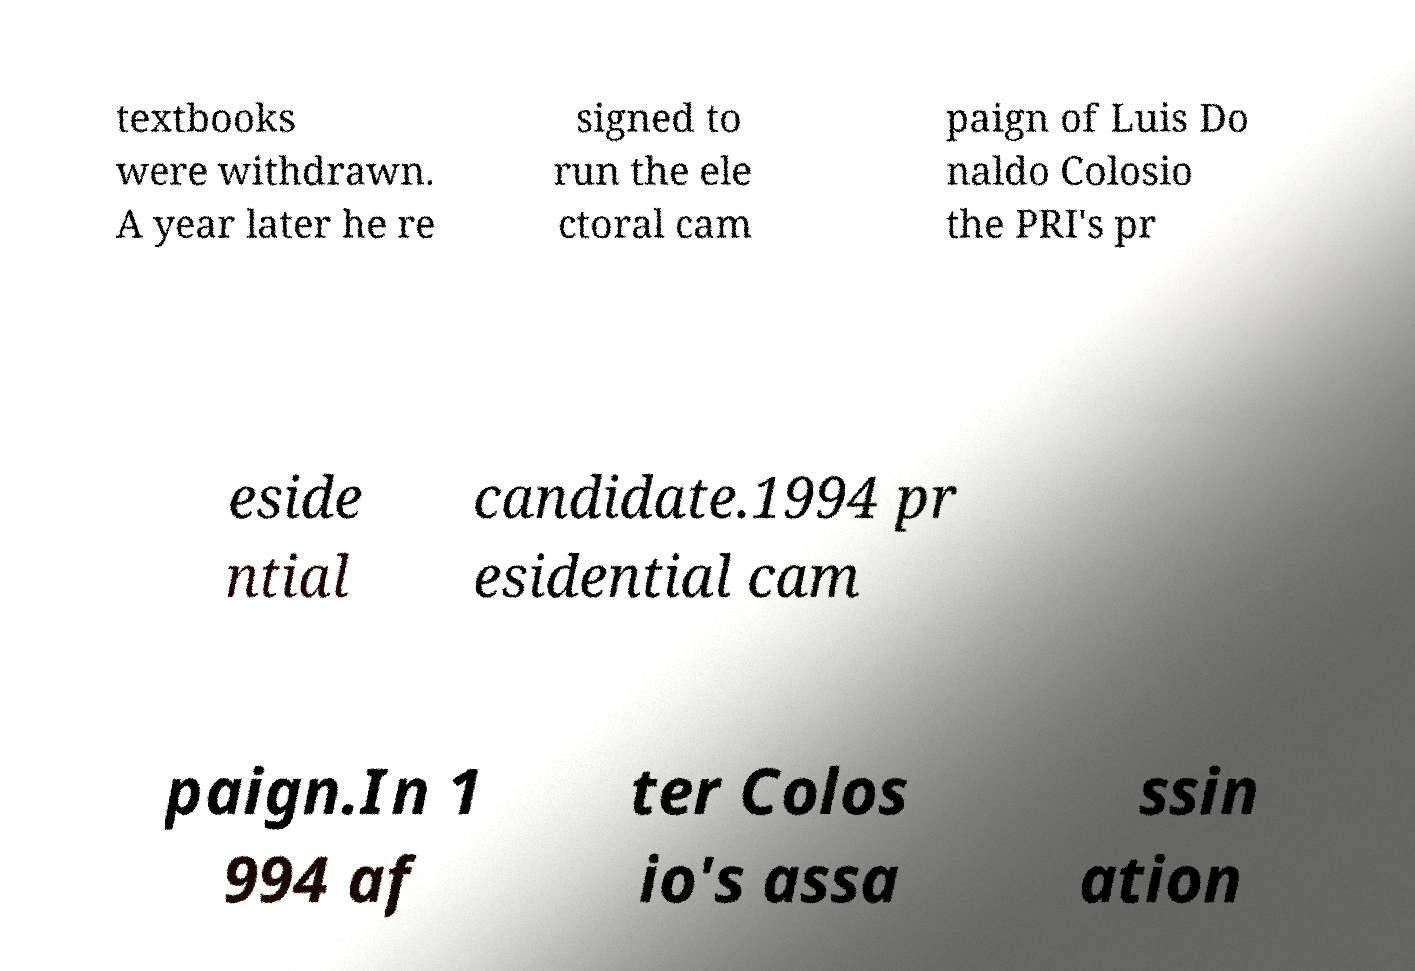For documentation purposes, I need the text within this image transcribed. Could you provide that? textbooks were withdrawn. A year later he re signed to run the ele ctoral cam paign of Luis Do naldo Colosio the PRI's pr eside ntial candidate.1994 pr esidential cam paign.In 1 994 af ter Colos io's assa ssin ation 